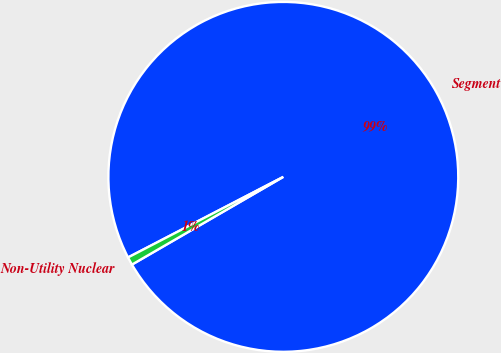<chart> <loc_0><loc_0><loc_500><loc_500><pie_chart><fcel>Segment<fcel>Non-Utility Nuclear<nl><fcel>99.26%<fcel>0.74%<nl></chart> 